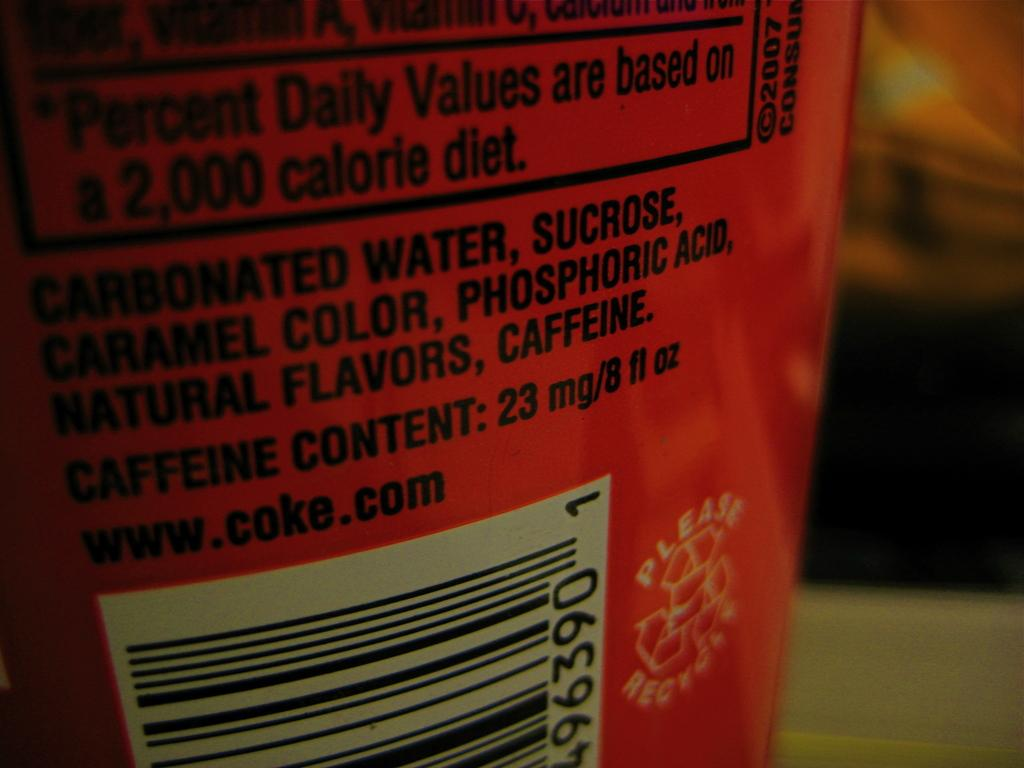<image>
Describe the image concisely. The first ingredient shown on this soda can is Carbonated Water. 